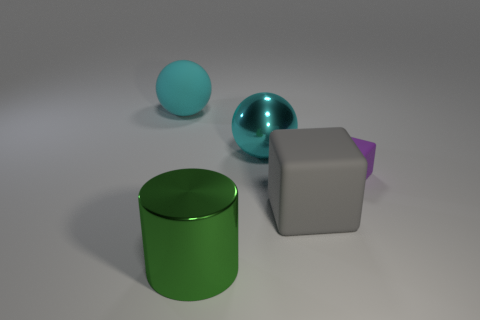Do the large gray object and the ball on the right side of the large green metal thing have the same material?
Offer a very short reply. No. There is a cyan sphere that is to the right of the cyan matte ball; what size is it?
Your answer should be very brief. Large. Is the number of big cyan objects less than the number of small green rubber balls?
Give a very brief answer. No. Are there any shiny spheres that have the same color as the large rubber ball?
Ensure brevity in your answer.  Yes. What is the shape of the thing that is on the left side of the big metallic sphere and behind the green object?
Offer a very short reply. Sphere. What shape is the rubber thing that is left of the large metallic thing behind the green metal object?
Make the answer very short. Sphere. Do the large gray matte object and the large green object have the same shape?
Offer a terse response. No. There is another big sphere that is the same color as the metallic ball; what is its material?
Make the answer very short. Rubber. Is the color of the metal sphere the same as the big rubber sphere?
Provide a short and direct response. Yes. There is a cyan sphere that is to the left of the green object that is to the right of the matte sphere; how many spheres are behind it?
Your response must be concise. 0. 